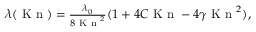<formula> <loc_0><loc_0><loc_500><loc_500>\begin{array} { r } { \lambda ( K n ) = \frac { \lambda _ { 0 } } { 8 K n ^ { 2 } } ( 1 + 4 C K n - 4 \gamma K n ^ { 2 } ) , } \end{array}</formula> 